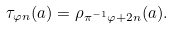<formula> <loc_0><loc_0><loc_500><loc_500>\tau _ { \varphi n } ( a ) = \rho _ { \pi ^ { - 1 } \varphi + 2 n } ( a ) .</formula> 